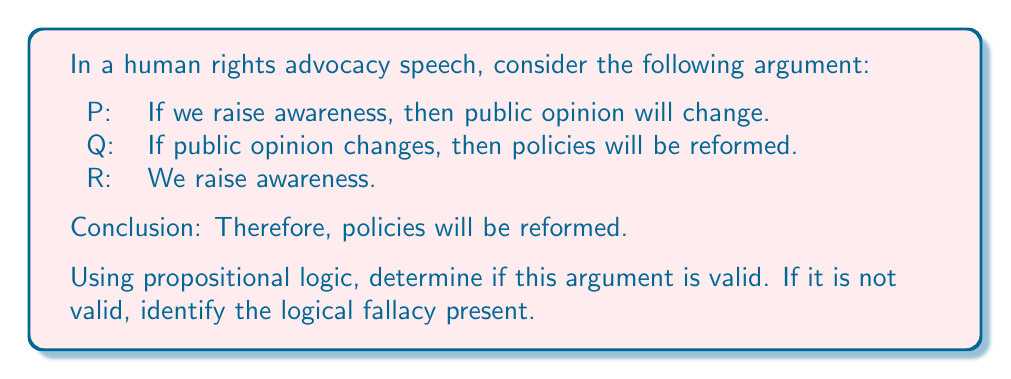Teach me how to tackle this problem. Let's approach this step-by-step using propositional logic:

1) First, let's translate the given statements into logical propositions:
   P: A → C (If we raise awareness, then public opinion will change)
   Q: C → R (If public opinion changes, then policies will be reformed)
   R: A (We raise awareness)

   Conclusion: R (Policies will be reformed)

2) The structure of the argument is:
   (A → C) ∧ (C → R) ∧ A ⊢ R

3) To check validity, we can use the method of natural deduction:

   1. A → C     (Given)
   2. C → R     (Given)
   3. A         (Given)
   4. C         (Modus Ponens, 1 and 3)
   5. R         (Modus Ponens, 2 and 4)

4) The conclusion R is indeed derived from the given premises. Therefore, the argument is valid.

5) This argument form is known as Hypothetical Syllogism combined with Modus Ponens. It can be represented as:

   $$ ((A \rightarrow C) \land (C \rightarrow R) \land A) \rightarrow R $$

   This is a tautology in propositional logic, which means it's always true regardless of the truth values of A, C, and R.

6) In the context of advocacy speeches, this logical structure demonstrates how a chain of causation can be used to argue for policy reform. However, it's important to note that while the argument is logically valid, its soundness depends on the truth of its premises in the real world.
Answer: The argument is valid. It follows the form of Hypothetical Syllogism combined with Modus Ponens, which is a valid argument form in propositional logic. 